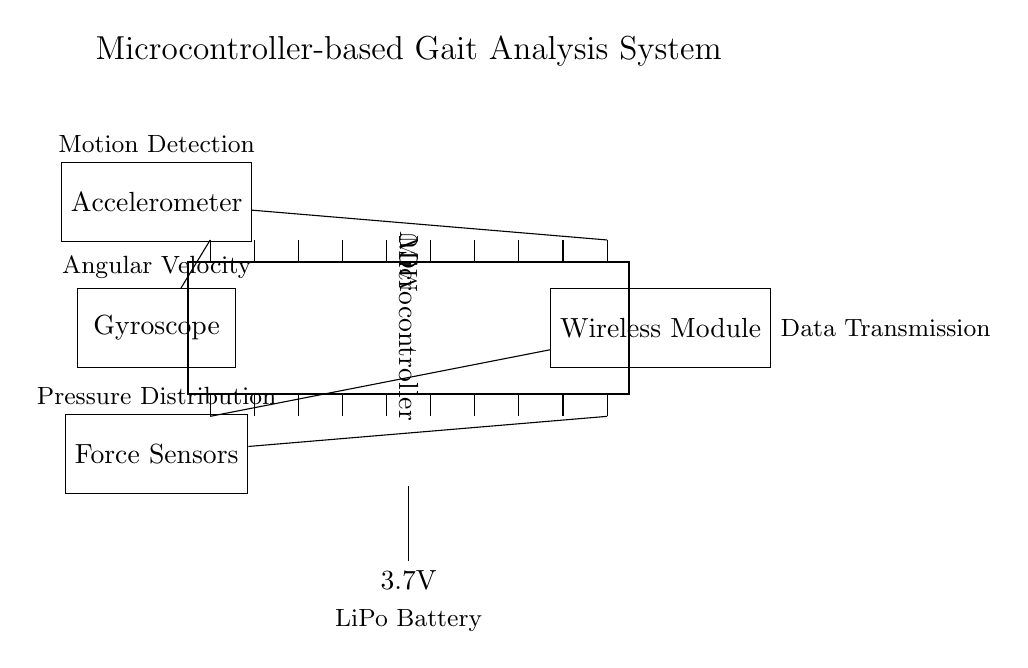What is the main component in this circuit? The main component is the microcontroller, which is indicated by the dipchip symbol and essential for processing sensor data.
Answer: microcontroller What type of sensors are integrated into the system? The diagram shows three types of sensors: an accelerometer, a gyroscope, and force sensors, each labeled above their respective components.
Answer: accelerometer, gyroscope, force sensors What is the purpose of the wireless module? The wireless module is responsible for transmitting data wirelessly, as indicated by the labeling next to it.
Answer: data transmission How many pins does the microcontroller have? The microcontroller in the diagram has 20 pins, as represented by the pin count next to the dipchip symbol.
Answer: 20 What is the power supply voltage for the circuit? The power supply is a 3.7V lithium polymer battery, clearly labeled in the schematic.
Answer: 3.7V Which sensor is connected to pin 20 of the microcontroller? According to the diagram, the force sensors are connected to pin 20, which is shown in the connection line leading to the sensor.
Answer: force sensors What does the accelerometer measure? The accelerometer measures motion detection, which is stated in the label positioned above it in the circuit diagram.
Answer: motion detection 